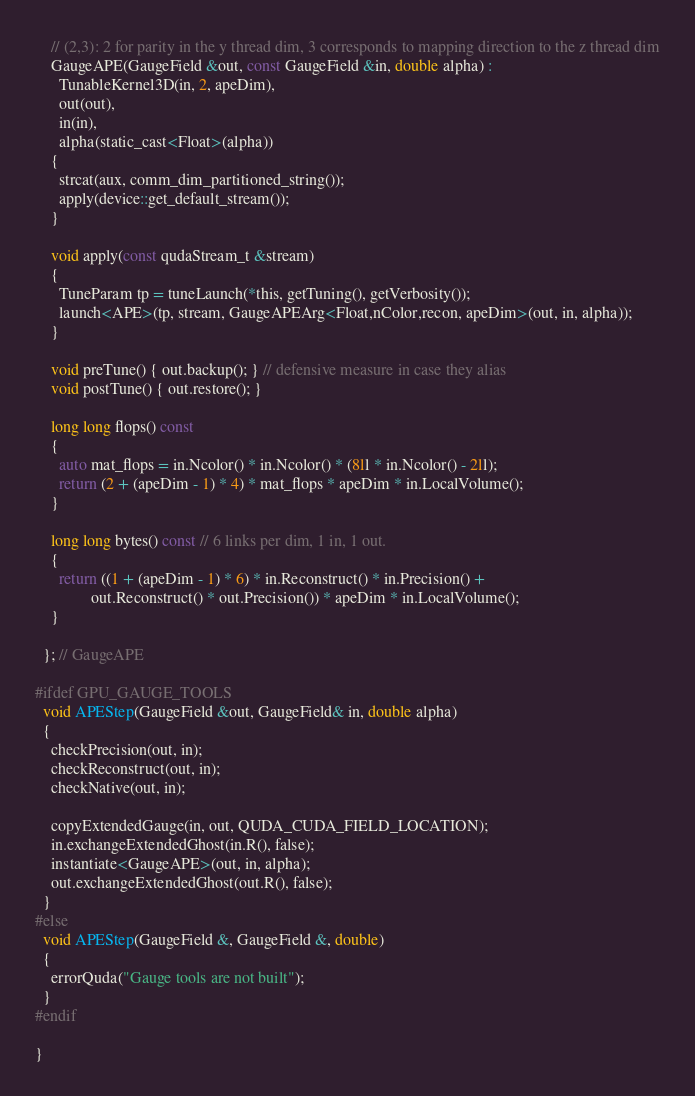<code> <loc_0><loc_0><loc_500><loc_500><_Cuda_>    // (2,3): 2 for parity in the y thread dim, 3 corresponds to mapping direction to the z thread dim
    GaugeAPE(GaugeField &out, const GaugeField &in, double alpha) :
      TunableKernel3D(in, 2, apeDim),
      out(out),
      in(in),
      alpha(static_cast<Float>(alpha))
    {
      strcat(aux, comm_dim_partitioned_string());
      apply(device::get_default_stream());
    }

    void apply(const qudaStream_t &stream)
    {
      TuneParam tp = tuneLaunch(*this, getTuning(), getVerbosity());
      launch<APE>(tp, stream, GaugeAPEArg<Float,nColor,recon, apeDim>(out, in, alpha));
    }

    void preTune() { out.backup(); } // defensive measure in case they alias
    void postTune() { out.restore(); }

    long long flops() const
    {
      auto mat_flops = in.Ncolor() * in.Ncolor() * (8ll * in.Ncolor() - 2ll);
      return (2 + (apeDim - 1) * 4) * mat_flops * apeDim * in.LocalVolume();
    }

    long long bytes() const // 6 links per dim, 1 in, 1 out.
    {
      return ((1 + (apeDim - 1) * 6) * in.Reconstruct() * in.Precision() +
              out.Reconstruct() * out.Precision()) * apeDim * in.LocalVolume();
    }

  }; // GaugeAPE

#ifdef GPU_GAUGE_TOOLS
  void APEStep(GaugeField &out, GaugeField& in, double alpha)
  {
    checkPrecision(out, in);
    checkReconstruct(out, in);
    checkNative(out, in);

    copyExtendedGauge(in, out, QUDA_CUDA_FIELD_LOCATION);
    in.exchangeExtendedGhost(in.R(), false);
    instantiate<GaugeAPE>(out, in, alpha);
    out.exchangeExtendedGhost(out.R(), false);
  }
#else
  void APEStep(GaugeField &, GaugeField &, double)
  {
    errorQuda("Gauge tools are not built");
  }
#endif

}
</code> 